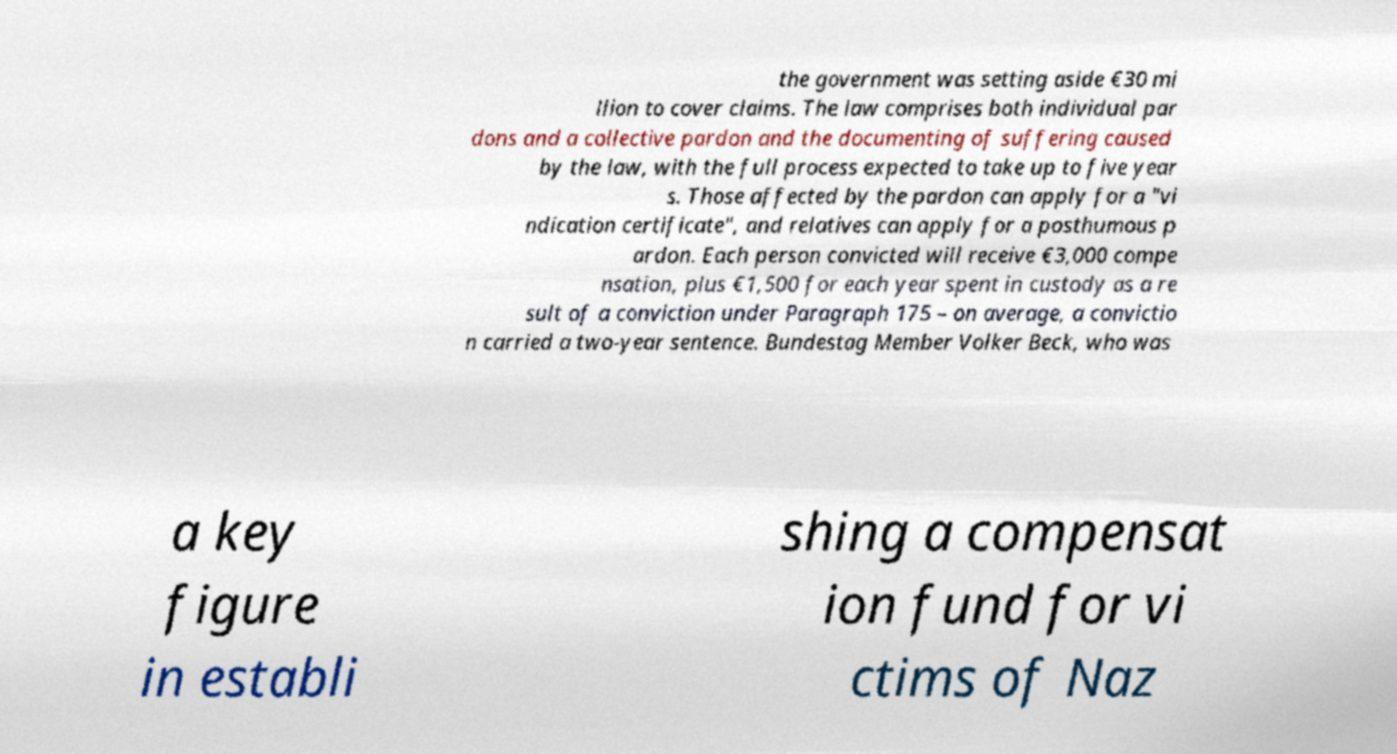There's text embedded in this image that I need extracted. Can you transcribe it verbatim? the government was setting aside €30 mi llion to cover claims. The law comprises both individual par dons and a collective pardon and the documenting of suffering caused by the law, with the full process expected to take up to five year s. Those affected by the pardon can apply for a "vi ndication certificate", and relatives can apply for a posthumous p ardon. Each person convicted will receive €3,000 compe nsation, plus €1,500 for each year spent in custody as a re sult of a conviction under Paragraph 175 – on average, a convictio n carried a two-year sentence. Bundestag Member Volker Beck, who was a key figure in establi shing a compensat ion fund for vi ctims of Naz 